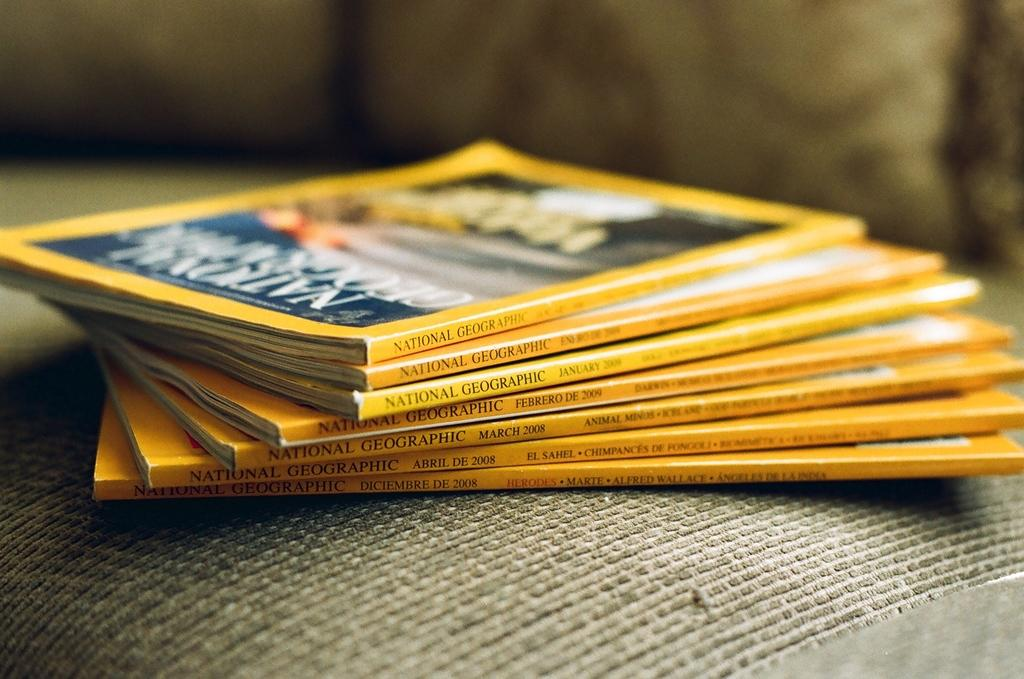<image>
Write a terse but informative summary of the picture. Seven National Geographic magazines are stacked on top of each other. 